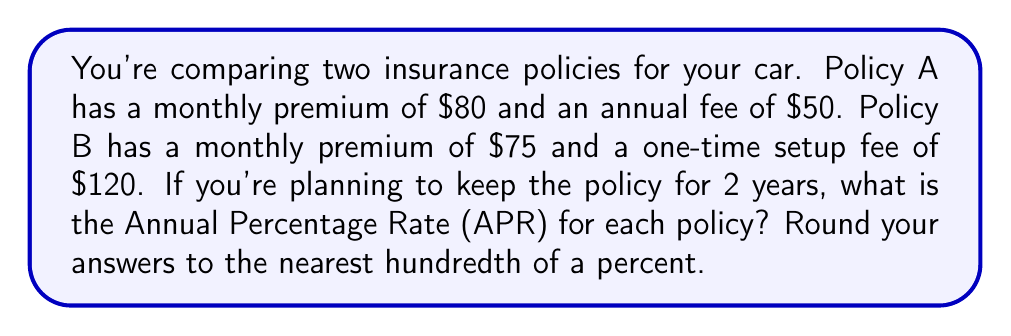Could you help me with this problem? To calculate the APR for each policy, we need to follow these steps:

1. Calculate the total cost over 2 years for each policy
2. Calculate the average annual cost
3. Determine the APR using the formula: $APR = \frac{\text{Annual Cost}}{\text{Initial Principal}} \times 100\%$

For Policy A:
1. Total cost over 2 years:
   $$(80 \times 12 \times 2) + (50 \times 2) = 1920 + 100 = $2020$$

2. Average annual cost:
   $$\frac{2020}{2} = $1010$$

3. APR calculation:
   $$APR_A = \frac{1010}{1920} \times 100\% = 52.60\%$$

For Policy B:
1. Total cost over 2 years:
   $$(75 \times 12 \times 2) + 120 = 1800 + 120 = $1920$$

2. Average annual cost:
   $$\frac{1920}{2} = $960$$

3. APR calculation:
   $$APR_B = \frac{960}{1800} \times 100\% = 53.33\%$$

Rounding to the nearest hundredth of a percent:
Policy A: 52.60%
Policy B: 53.33%
Answer: Policy A APR: 52.60%
Policy B APR: 53.33% 